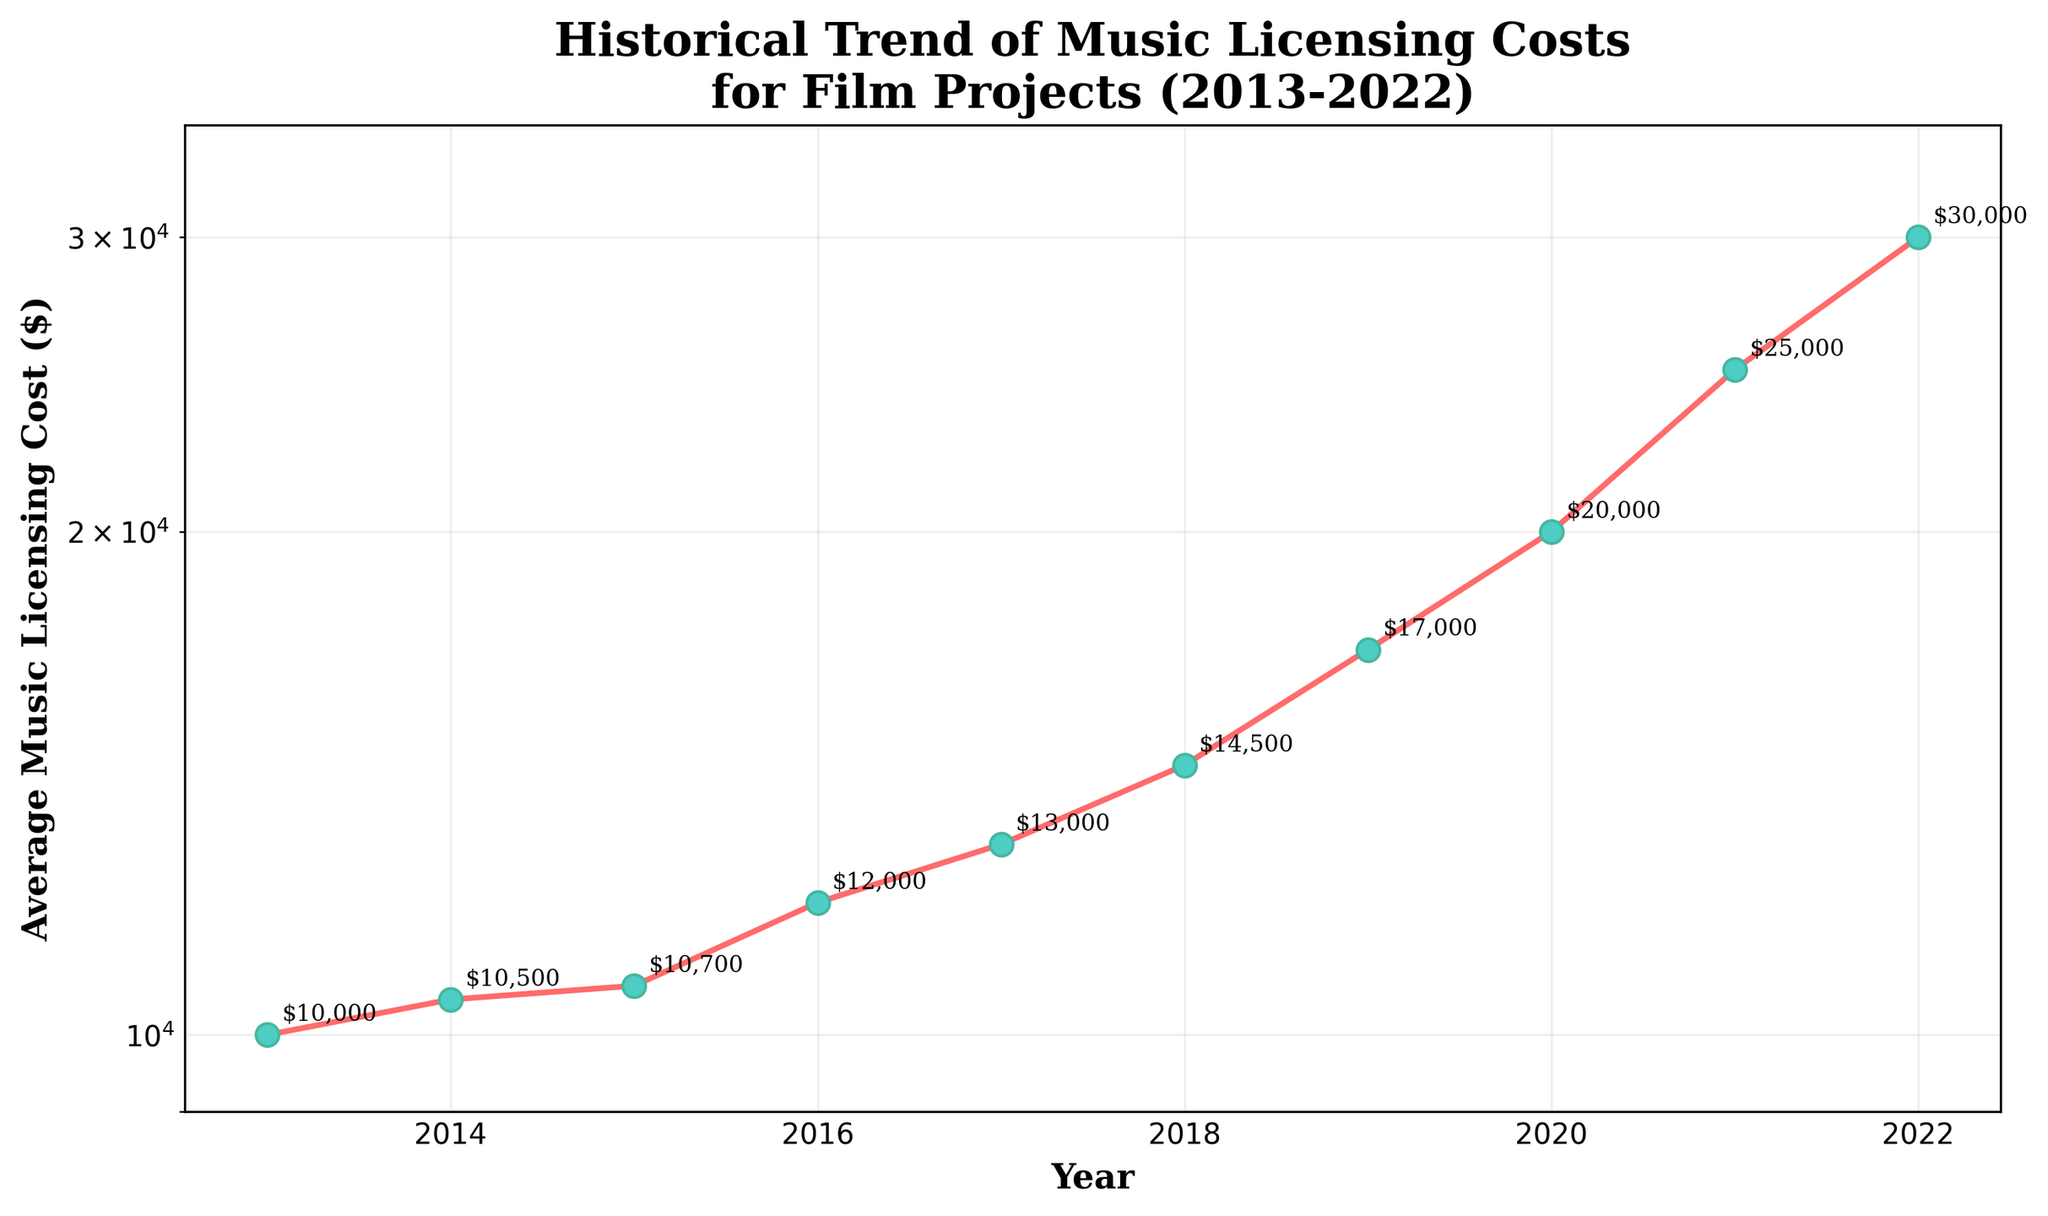What's the title of the figure? The title of the figure is generally found at the top and provides a summary of what the figure is depicting. In this case, it reads "Historical Trend of Music Licensing Costs for Film Projects (2013-2022)".
Answer: Historical Trend of Music Licensing Costs for Film Projects (2013-2022) What is the average music licensing cost in 2016? Look at the data point on the plot corresponding to the year 2016. The y-value (vertical height) at that point indicates the cost.
Answer: $12,000 How much did the average music licensing cost increase from 2014 to 2019? First, find the costs for 2014 and 2019 from the y-values. Subtract the 2014 value from the 2019 value to find the difference. $17,000 - $10,500 = $6,500
Answer: $6,500 Which year saw the highest average music licensing cost? Identify the highest point on the plot and note the corresponding year on the x-axis.
Answer: 2022 Which year had the lowest average music licensing cost? Identify the lowest point on the plot and note the corresponding year on the x-axis.
Answer: 2013 How does the cost in 2021 compare to the cost in 2018? Compare the y-values of the data points for 2021 and 2018. 2021's cost ($25,000) is higher than 2018's cost ($14,500).
Answer: Higher How much did the average music licensing cost change from 2013 to 2022? Subtract the cost in 2013 from the cost in 2022. $30,000 - $10,000 = $20,000
Answer: $20,000 What pattern or trend in music licensing costs can you observe from 2013 to 2022? The plot shows an increasing trend in costs over the years as each successive year generally has a higher y-value compared to the previous year.
Answer: Increasing Between which consecutive years was the increase in average music licensing cost the greatest? Examine the differences in y-values between each pair of consecutive years. The largest increase is between 2020 ($20,000) and 2021 ($25,000), which is an increase of $5,000.
Answer: 2020 and 2021 Why is a log scale used on the y-axis in this plot? A log scale is often used for y-axes when the range of values is large or when the rate of change is exponential. This helps in more accurately visualizing the data where smaller values don't get dwarfed by larger ones.
Answer: To handle a wide range of values and rate of change 